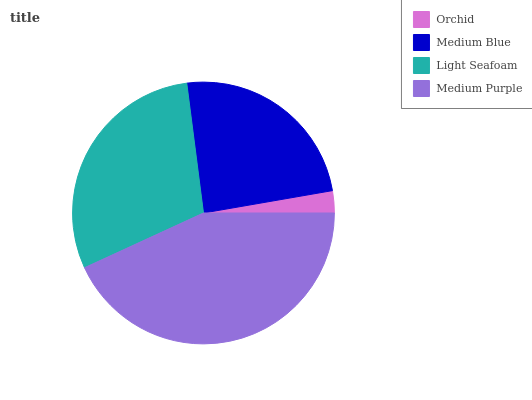Is Orchid the minimum?
Answer yes or no. Yes. Is Medium Purple the maximum?
Answer yes or no. Yes. Is Medium Blue the minimum?
Answer yes or no. No. Is Medium Blue the maximum?
Answer yes or no. No. Is Medium Blue greater than Orchid?
Answer yes or no. Yes. Is Orchid less than Medium Blue?
Answer yes or no. Yes. Is Orchid greater than Medium Blue?
Answer yes or no. No. Is Medium Blue less than Orchid?
Answer yes or no. No. Is Light Seafoam the high median?
Answer yes or no. Yes. Is Medium Blue the low median?
Answer yes or no. Yes. Is Medium Blue the high median?
Answer yes or no. No. Is Orchid the low median?
Answer yes or no. No. 